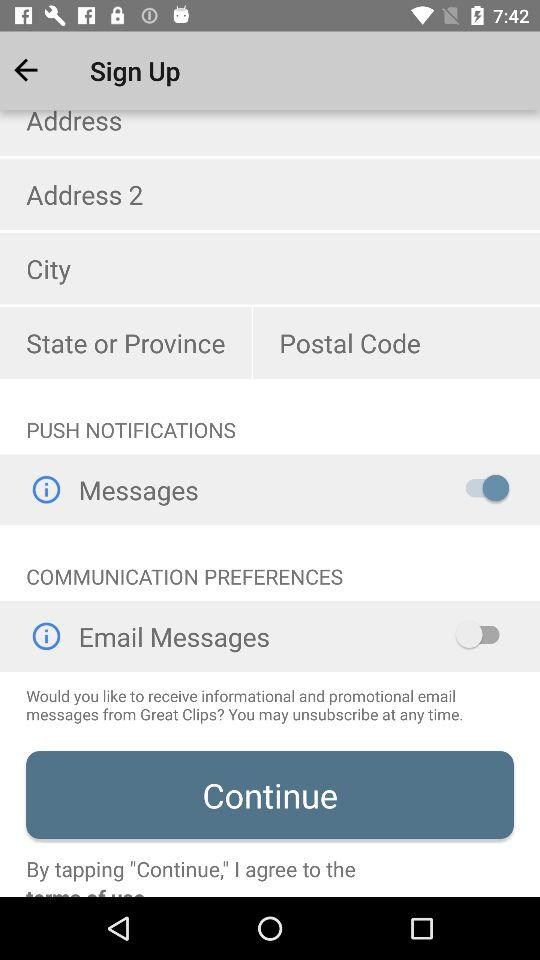What is the status of "Email Messages" in "COMMUNICATION PREFERENCES"? The status is "off". 